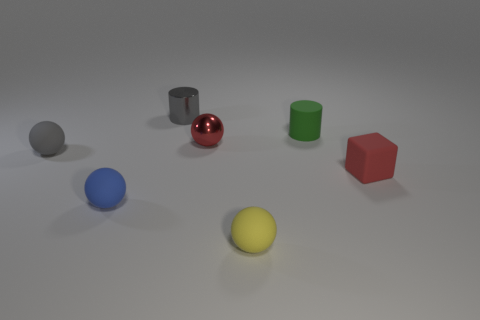Is the number of tiny blue matte things that are to the left of the metal cylinder the same as the number of gray matte spheres in front of the small gray rubber ball?
Your answer should be compact. No. There is a rubber ball in front of the blue object; what size is it?
Your response must be concise. Small. Is the small cube the same color as the small rubber cylinder?
Provide a succinct answer. No. Is there anything else that has the same shape as the tiny yellow matte object?
Your answer should be very brief. Yes. There is a tiny thing that is the same color as the small block; what is its material?
Offer a terse response. Metal. Is the number of tiny red shiny balls behind the gray shiny object the same as the number of small brown balls?
Make the answer very short. Yes. Are there any small red things on the left side of the shiny sphere?
Keep it short and to the point. No. Does the green rubber thing have the same shape as the metal object that is behind the red metal thing?
Offer a very short reply. Yes. There is a tiny block that is the same material as the green cylinder; what color is it?
Your answer should be compact. Red. What is the color of the metal sphere?
Give a very brief answer. Red. 